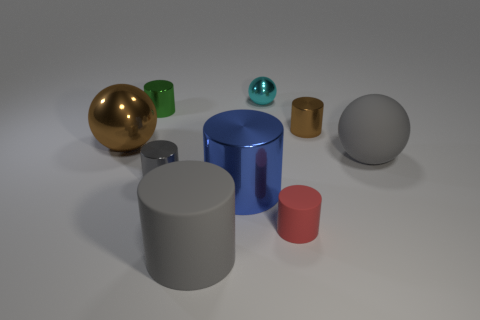Are there any large shiny things that have the same color as the small metal ball?
Make the answer very short. No. Are there an equal number of gray objects that are right of the blue shiny cylinder and big gray matte cylinders?
Your response must be concise. Yes. What number of large brown shiny spheres are there?
Offer a terse response. 1. What shape is the large object that is left of the gray matte ball and behind the small gray shiny cylinder?
Keep it short and to the point. Sphere. Does the small object in front of the tiny gray shiny thing have the same color as the tiny metallic object behind the green metallic cylinder?
Keep it short and to the point. No. The thing that is the same color as the big metallic ball is what size?
Offer a terse response. Small. Is there a green cylinder that has the same material as the big gray cylinder?
Provide a short and direct response. No. Are there the same number of gray things that are on the left side of the blue metal cylinder and small green cylinders to the left of the small red matte thing?
Keep it short and to the point. No. There is a ball to the left of the gray metal thing; how big is it?
Give a very brief answer. Large. There is a brown thing that is right of the rubber thing that is in front of the small red matte thing; what is it made of?
Offer a terse response. Metal. 